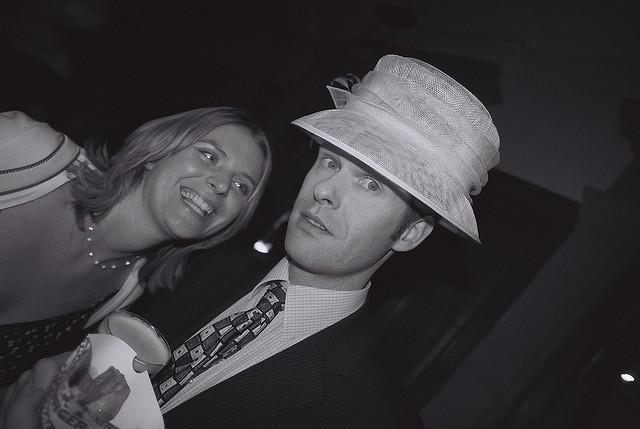How many hats?
Give a very brief answer. 1. How many people are in the photo?
Give a very brief answer. 2. How many people can you see?
Give a very brief answer. 2. 